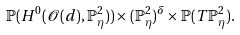<formula> <loc_0><loc_0><loc_500><loc_500>\mathbb { P } ( H ^ { 0 } ( \mathcal { O } ( d ) , \mathbb { P } ^ { 2 } _ { \eta } ) ) \times ( \mathbb { P } ^ { 2 } _ { \eta } ) ^ { \delta } \times \mathbb { P } ( T \mathbb { P } ^ { 2 } _ { \eta } ) .</formula> 